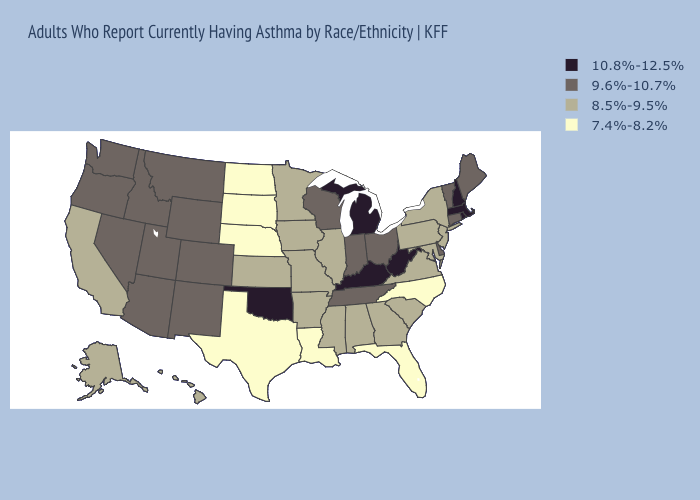What is the highest value in states that border California?
Answer briefly. 9.6%-10.7%. Among the states that border Wyoming , does Colorado have the highest value?
Be succinct. Yes. Does Nebraska have the lowest value in the MidWest?
Write a very short answer. Yes. What is the highest value in states that border Colorado?
Be succinct. 10.8%-12.5%. Name the states that have a value in the range 10.8%-12.5%?
Keep it brief. Kentucky, Massachusetts, Michigan, New Hampshire, Oklahoma, Rhode Island, West Virginia. Name the states that have a value in the range 7.4%-8.2%?
Answer briefly. Florida, Louisiana, Nebraska, North Carolina, North Dakota, South Dakota, Texas. Does Mississippi have a lower value than Oregon?
Short answer required. Yes. Among the states that border Ohio , does Kentucky have the highest value?
Write a very short answer. Yes. Does the map have missing data?
Quick response, please. No. Among the states that border New Jersey , which have the lowest value?
Concise answer only. New York, Pennsylvania. Among the states that border Kentucky , which have the lowest value?
Answer briefly. Illinois, Missouri, Virginia. What is the lowest value in states that border Arizona?
Quick response, please. 8.5%-9.5%. Name the states that have a value in the range 8.5%-9.5%?
Keep it brief. Alabama, Alaska, Arkansas, California, Georgia, Hawaii, Illinois, Iowa, Kansas, Maryland, Minnesota, Mississippi, Missouri, New Jersey, New York, Pennsylvania, South Carolina, Virginia. Name the states that have a value in the range 10.8%-12.5%?
Give a very brief answer. Kentucky, Massachusetts, Michigan, New Hampshire, Oklahoma, Rhode Island, West Virginia. Does Louisiana have the lowest value in the USA?
Be succinct. Yes. 